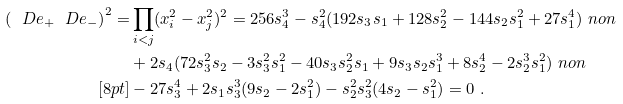<formula> <loc_0><loc_0><loc_500><loc_500>\left ( \ D e _ { + } \ D e _ { - } \right ) ^ { 2 } = & \prod _ { i < j } ( x _ { i } ^ { 2 } - x _ { j } ^ { 2 } ) ^ { 2 } = 2 5 6 s _ { 4 } ^ { 3 } - s _ { 4 } ^ { 2 } ( 1 9 2 s _ { 3 } s _ { 1 } + 1 2 8 s _ { 2 } ^ { 2 } - 1 4 4 s _ { 2 } s _ { 1 } ^ { 2 } + 2 7 s _ { 1 } ^ { 4 } ) \ n o n \\ & + 2 s _ { 4 } ( 7 2 s _ { 3 } ^ { 2 } s _ { 2 } - 3 s _ { 3 } ^ { 2 } s _ { 1 } ^ { 2 } - 4 0 s _ { 3 } s _ { 2 } ^ { 2 } s _ { 1 } + 9 s _ { 3 } s _ { 2 } s _ { 1 } ^ { 3 } + 8 s _ { 2 } ^ { 4 } - 2 s _ { 2 } ^ { 3 } s _ { 1 } ^ { 2 } ) \ n o n \\ [ 8 p t ] & - 2 7 s _ { 3 } ^ { 4 } + 2 s _ { 1 } s _ { 3 } ^ { 3 } ( 9 s _ { 2 } - 2 s _ { 1 } ^ { 2 } ) - s _ { 2 } ^ { 2 } s _ { 3 } ^ { 2 } ( 4 s _ { 2 } - s _ { 1 } ^ { 2 } ) = 0 \ .</formula> 